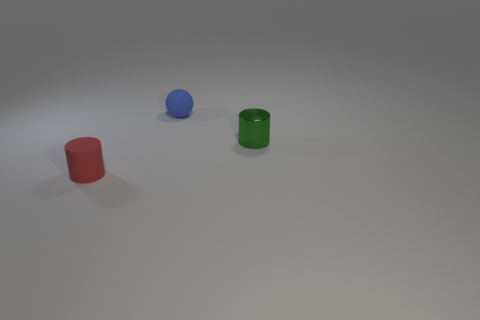What number of green objects are either tiny matte balls or small matte cylinders?
Make the answer very short. 0. What number of other rubber balls are the same color as the small ball?
Make the answer very short. 0. Is the tiny red cylinder made of the same material as the small blue sphere?
Your answer should be very brief. Yes. There is a matte object that is behind the tiny metal object; how many tiny red things are behind it?
Offer a terse response. 0. Is the blue matte object the same size as the green object?
Provide a short and direct response. Yes. How many tiny green objects have the same material as the tiny blue ball?
Make the answer very short. 0. The rubber thing that is the same shape as the small metal thing is what size?
Your response must be concise. Small. There is a matte thing behind the small red rubber cylinder; does it have the same shape as the tiny red matte thing?
Provide a succinct answer. No. What shape is the tiny matte object behind the small object in front of the tiny green metallic object?
Make the answer very short. Sphere. Is there anything else that is the same shape as the small shiny thing?
Make the answer very short. Yes. 